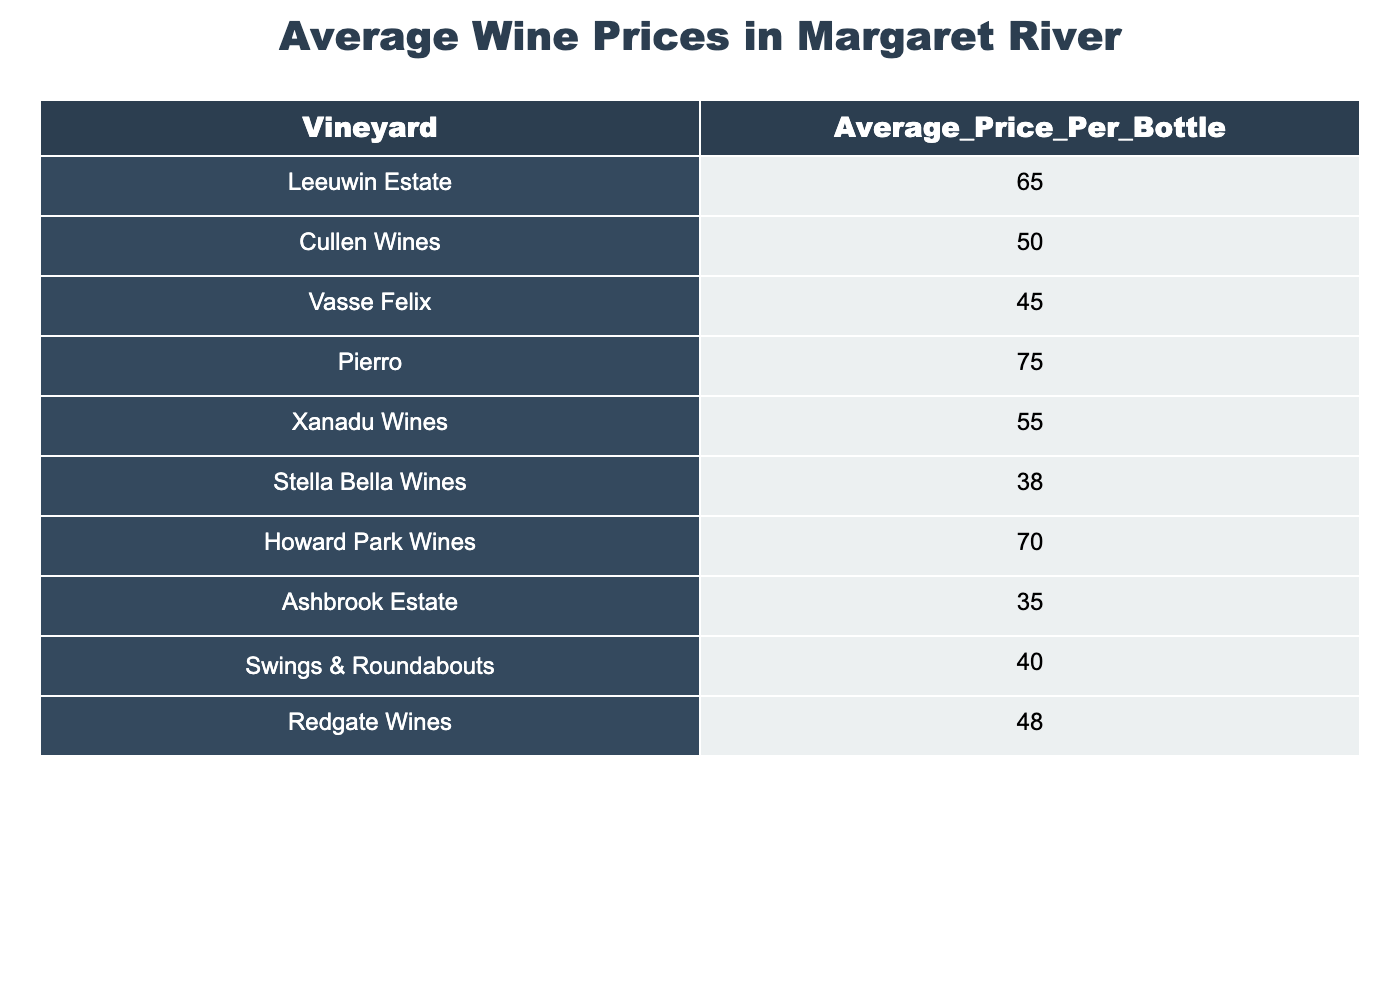What is the average price per bottle at Leeuwin Estate? The table shows that the average price per bottle at Leeuwin Estate is directly listed as 65.
Answer: 65 Which vineyard has the lowest average price per bottle? The table lists Stella Bella Wines with an average price of 38, which is lower than all other vineyards.
Answer: Stella Bella Wines Calculate the difference in average price per bottle between Pierro and Ashbrook Estate? Pierro has an average price of 75 and Ashbrook Estate has 35. The difference is 75 - 35 = 40.
Answer: 40 What is the average price per bottle for Howard Park Wines and Vasse Felix? The average price for Howard Park Wines is 70 and for Vasse Felix is 45. Adding them gives 70 + 45 = 115, then dividing by 2 results in 115 / 2 = 57.5.
Answer: 57.5 Which vineyard’s price per bottle is greater than the average price of all vineyards combined? First, sum all average prices: (65 + 50 + 45 + 75 + 55 + 38 + 70 + 35 + 40 + 48) =  476. The average price is 476 / 10 = 47.6. Prices greater than 47.6 are from Leeuwin Estate, Pierro, Xanadu Wines, Howard Park Wines.
Answer: Leeuwin Estate, Pierro, Xanadu Wines, Howard Park Wines Is the average price per bottle for Vasse Felix lower than that of Redgate Wines? The average price for Vasse Felix is 45 and for Redgate Wines is 48. Since 45 < 48, the statement is true.
Answer: Yes Which vineyard has a price that is $20 more than the average price of Stella Bella Wines? The average price for Stella Bella Wines is 38, adding $20 gives 38 + 20 = 58. The vineyard with the price closest to this in the table is Xanadu Wines at 55.
Answer: Xanadu Wines If you combine the average prices for Ashbrook Estate and Swings & Roundabouts, what would that total be? The price for Ashbrook Estate is 35 and for Swings & Roundabouts is 40. Adding these gives 35 + 40 = 75.
Answer: 75 How many vineyards have an average price of less than 50? The vineyards with prices less than 50 are Stella Bella Wines (38), Ashbrook Estate (35), and Swings & Roundabouts (40), a total of 3 vineyards.
Answer: 3 What is the median average price per bottle among the vineyards shown? To find the median, list the average prices in order: 35, 38, 40, 45, 48, 50, 55, 65, 70, 75. The median is the average of the 5th and 6th values: (48 + 50) / 2 = 49.
Answer: 49 